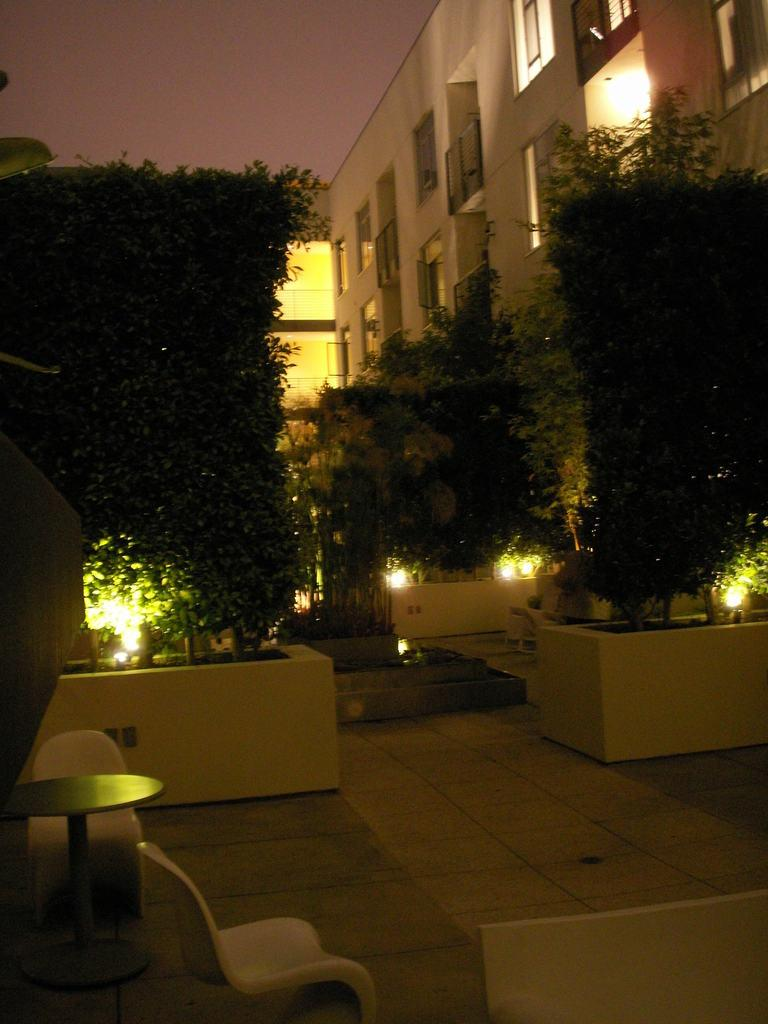What is located on the left side of the image? There is a table on the left side of the image. What furniture is near the table? There are two chairs near the table. What can be seen in the background of the image? The sky, trees, buildings, and lights are visible in the background of the image. What type of chalk is being used to draw on the table in the image? There is no chalk present in the image, and no drawing activity is taking place on the table. Can you tell me how many friends are sitting at the table in the image? There is no mention of friends or people sitting at the table in the image; only the table, chairs, and background elements are visible. 